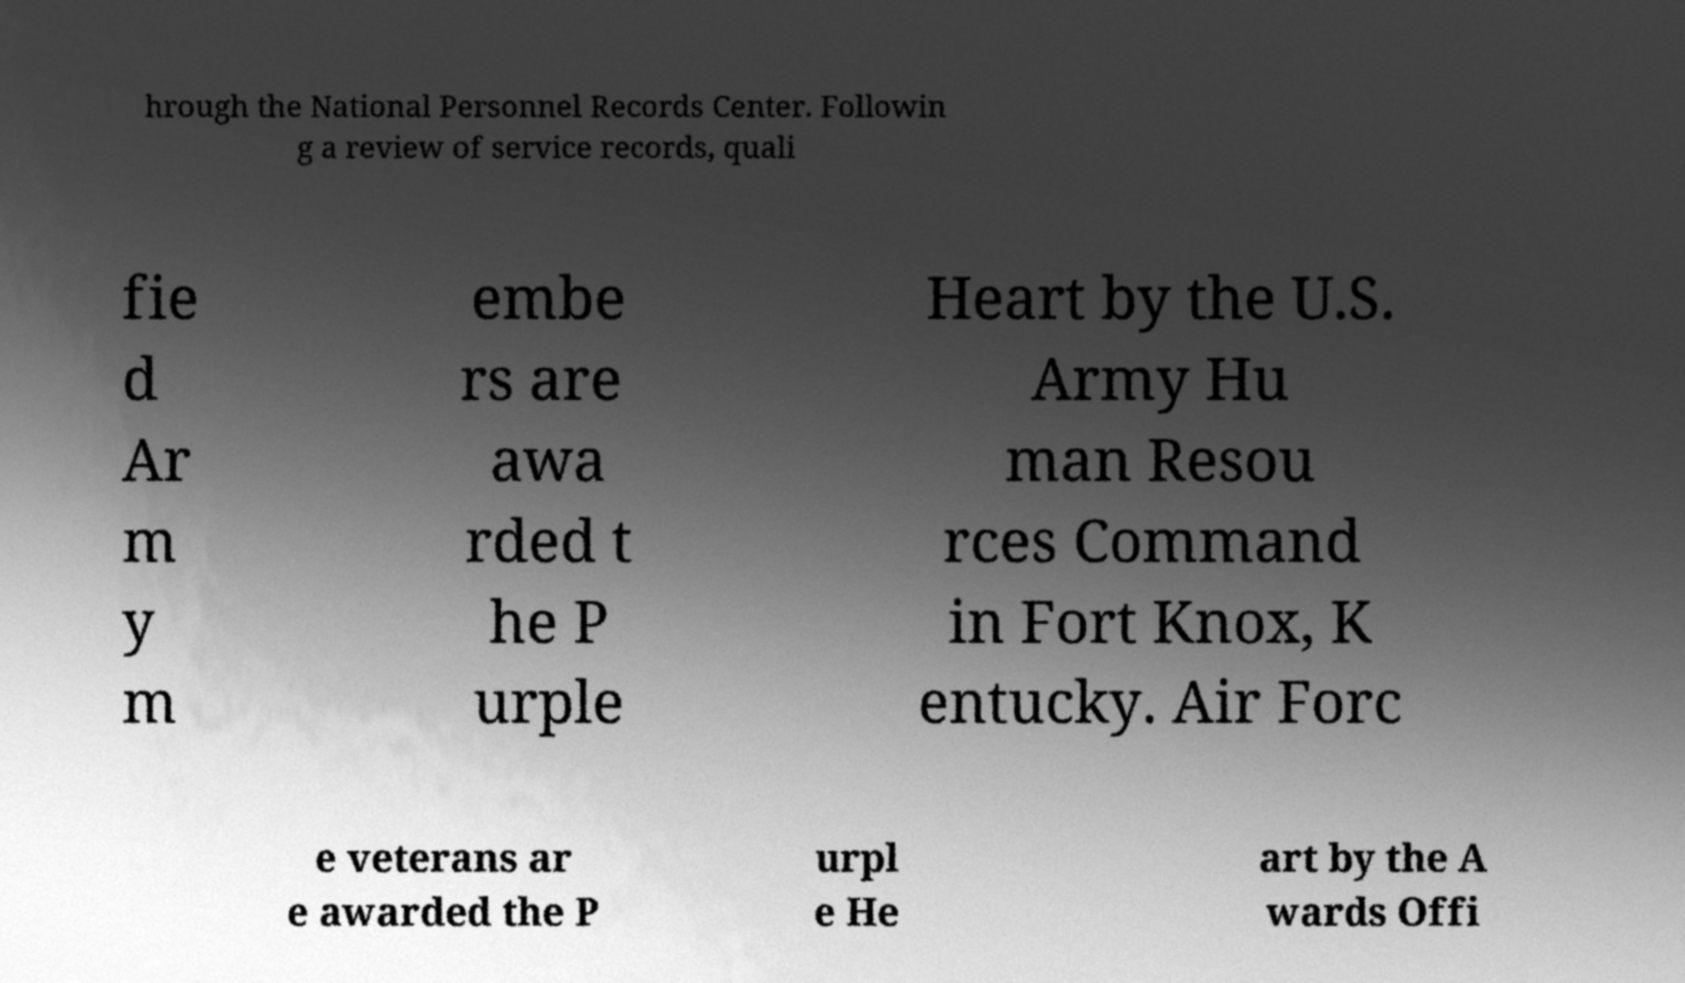I need the written content from this picture converted into text. Can you do that? hrough the National Personnel Records Center. Followin g a review of service records, quali fie d Ar m y m embe rs are awa rded t he P urple Heart by the U.S. Army Hu man Resou rces Command in Fort Knox, K entucky. Air Forc e veterans ar e awarded the P urpl e He art by the A wards Offi 